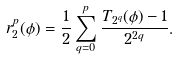<formula> <loc_0><loc_0><loc_500><loc_500>r _ { 2 } ^ { p } ( \phi ) = \frac { 1 } { 2 } \sum _ { q = 0 } ^ { p } \frac { T _ { 2 ^ { q } } ( \phi ) - 1 } { 2 ^ { 2 q } } .</formula> 